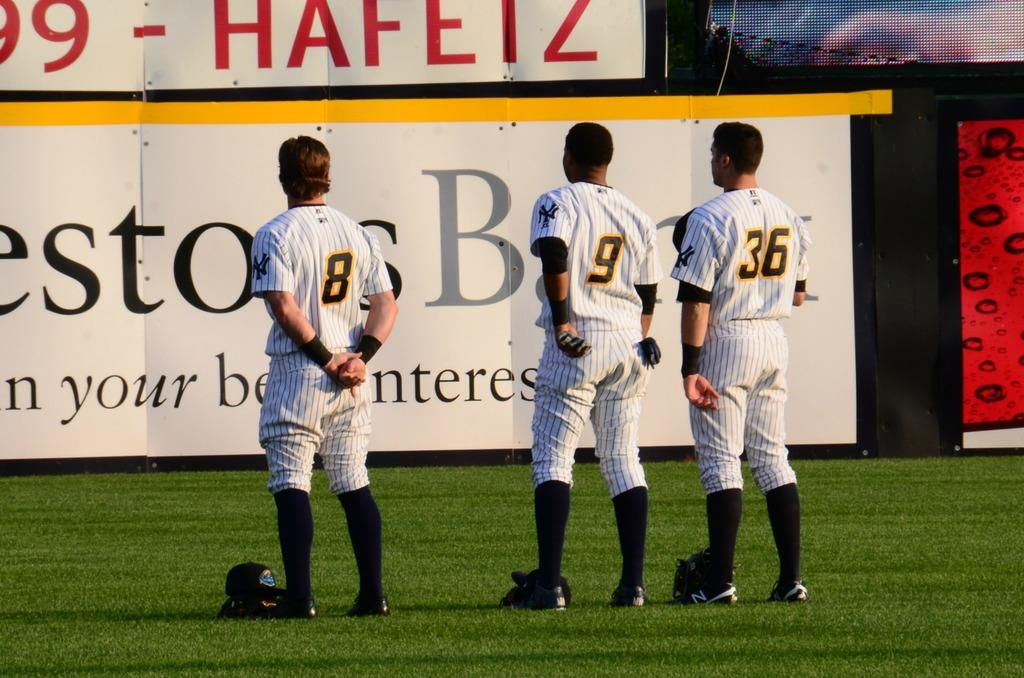<image>
Offer a succinct explanation of the picture presented. Baseball player wearing number 8 standing next to one wearing number 9. 